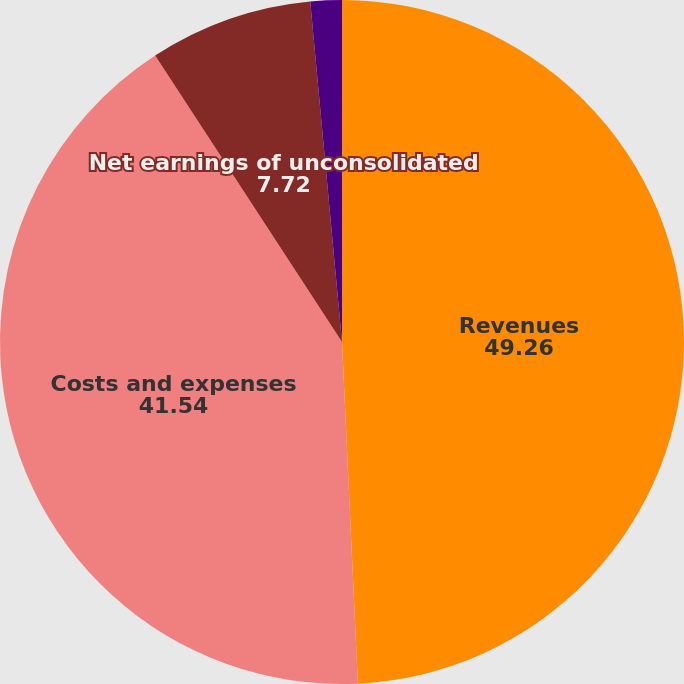Convert chart to OTSL. <chart><loc_0><loc_0><loc_500><loc_500><pie_chart><fcel>Revenues<fcel>Costs and expenses<fcel>Net earnings of unconsolidated<fcel>Company's share of net<nl><fcel>49.26%<fcel>41.54%<fcel>7.72%<fcel>1.48%<nl></chart> 